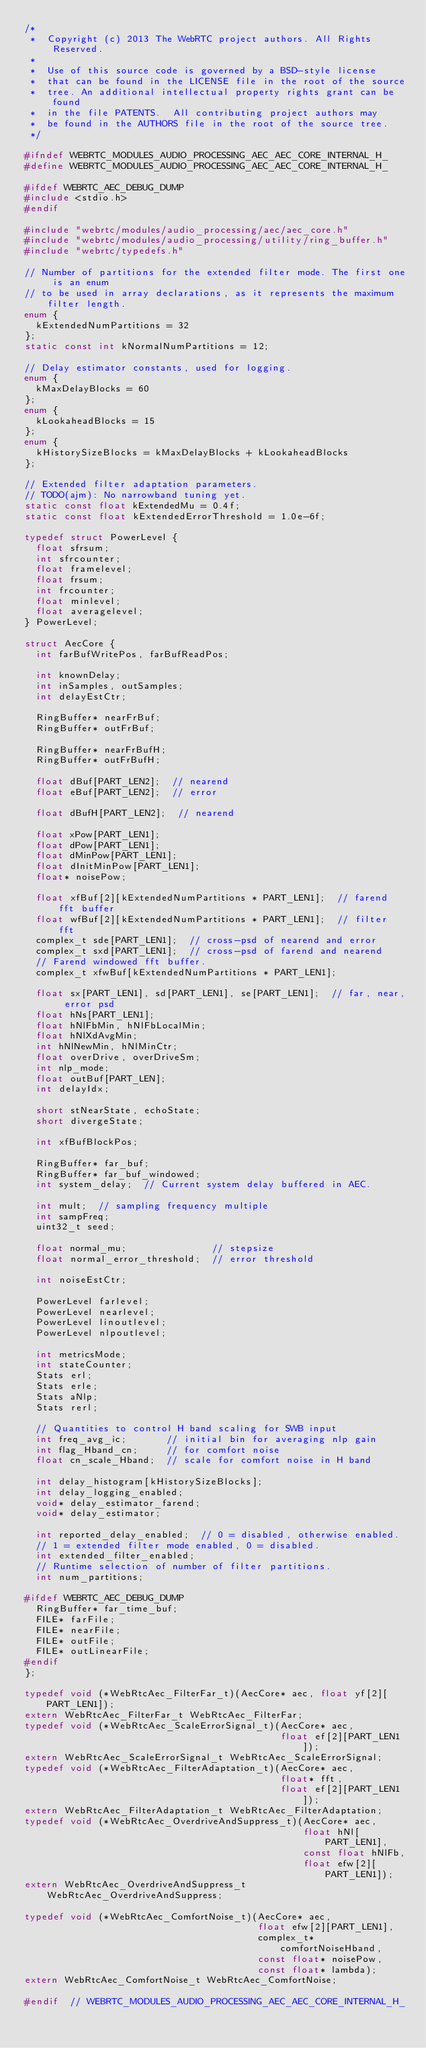<code> <loc_0><loc_0><loc_500><loc_500><_C_>/*
 *  Copyright (c) 2013 The WebRTC project authors. All Rights Reserved.
 *
 *  Use of this source code is governed by a BSD-style license
 *  that can be found in the LICENSE file in the root of the source
 *  tree. An additional intellectual property rights grant can be found
 *  in the file PATENTS.  All contributing project authors may
 *  be found in the AUTHORS file in the root of the source tree.
 */

#ifndef WEBRTC_MODULES_AUDIO_PROCESSING_AEC_AEC_CORE_INTERNAL_H_
#define WEBRTC_MODULES_AUDIO_PROCESSING_AEC_AEC_CORE_INTERNAL_H_

#ifdef WEBRTC_AEC_DEBUG_DUMP
#include <stdio.h>
#endif

#include "webrtc/modules/audio_processing/aec/aec_core.h"
#include "webrtc/modules/audio_processing/utility/ring_buffer.h"
#include "webrtc/typedefs.h"

// Number of partitions for the extended filter mode. The first one is an enum
// to be used in array declarations, as it represents the maximum filter length.
enum {
  kExtendedNumPartitions = 32
};
static const int kNormalNumPartitions = 12;

// Delay estimator constants, used for logging.
enum {
  kMaxDelayBlocks = 60
};
enum {
  kLookaheadBlocks = 15
};
enum {
  kHistorySizeBlocks = kMaxDelayBlocks + kLookaheadBlocks
};

// Extended filter adaptation parameters.
// TODO(ajm): No narrowband tuning yet.
static const float kExtendedMu = 0.4f;
static const float kExtendedErrorThreshold = 1.0e-6f;

typedef struct PowerLevel {
  float sfrsum;
  int sfrcounter;
  float framelevel;
  float frsum;
  int frcounter;
  float minlevel;
  float averagelevel;
} PowerLevel;

struct AecCore {
  int farBufWritePos, farBufReadPos;

  int knownDelay;
  int inSamples, outSamples;
  int delayEstCtr;

  RingBuffer* nearFrBuf;
  RingBuffer* outFrBuf;

  RingBuffer* nearFrBufH;
  RingBuffer* outFrBufH;

  float dBuf[PART_LEN2];  // nearend
  float eBuf[PART_LEN2];  // error

  float dBufH[PART_LEN2];  // nearend

  float xPow[PART_LEN1];
  float dPow[PART_LEN1];
  float dMinPow[PART_LEN1];
  float dInitMinPow[PART_LEN1];
  float* noisePow;

  float xfBuf[2][kExtendedNumPartitions * PART_LEN1];  // farend fft buffer
  float wfBuf[2][kExtendedNumPartitions * PART_LEN1];  // filter fft
  complex_t sde[PART_LEN1];  // cross-psd of nearend and error
  complex_t sxd[PART_LEN1];  // cross-psd of farend and nearend
  // Farend windowed fft buffer.
  complex_t xfwBuf[kExtendedNumPartitions * PART_LEN1];

  float sx[PART_LEN1], sd[PART_LEN1], se[PART_LEN1];  // far, near, error psd
  float hNs[PART_LEN1];
  float hNlFbMin, hNlFbLocalMin;
  float hNlXdAvgMin;
  int hNlNewMin, hNlMinCtr;
  float overDrive, overDriveSm;
  int nlp_mode;
  float outBuf[PART_LEN];
  int delayIdx;

  short stNearState, echoState;
  short divergeState;

  int xfBufBlockPos;

  RingBuffer* far_buf;
  RingBuffer* far_buf_windowed;
  int system_delay;  // Current system delay buffered in AEC.

  int mult;  // sampling frequency multiple
  int sampFreq;
  uint32_t seed;

  float normal_mu;               // stepsize
  float normal_error_threshold;  // error threshold

  int noiseEstCtr;

  PowerLevel farlevel;
  PowerLevel nearlevel;
  PowerLevel linoutlevel;
  PowerLevel nlpoutlevel;

  int metricsMode;
  int stateCounter;
  Stats erl;
  Stats erle;
  Stats aNlp;
  Stats rerl;

  // Quantities to control H band scaling for SWB input
  int freq_avg_ic;       // initial bin for averaging nlp gain
  int flag_Hband_cn;     // for comfort noise
  float cn_scale_Hband;  // scale for comfort noise in H band

  int delay_histogram[kHistorySizeBlocks];
  int delay_logging_enabled;
  void* delay_estimator_farend;
  void* delay_estimator;

  int reported_delay_enabled;  // 0 = disabled, otherwise enabled.
  // 1 = extended filter mode enabled, 0 = disabled.
  int extended_filter_enabled;
  // Runtime selection of number of filter partitions.
  int num_partitions;

#ifdef WEBRTC_AEC_DEBUG_DUMP
  RingBuffer* far_time_buf;
  FILE* farFile;
  FILE* nearFile;
  FILE* outFile;
  FILE* outLinearFile;
#endif
};

typedef void (*WebRtcAec_FilterFar_t)(AecCore* aec, float yf[2][PART_LEN1]);
extern WebRtcAec_FilterFar_t WebRtcAec_FilterFar;
typedef void (*WebRtcAec_ScaleErrorSignal_t)(AecCore* aec,
                                             float ef[2][PART_LEN1]);
extern WebRtcAec_ScaleErrorSignal_t WebRtcAec_ScaleErrorSignal;
typedef void (*WebRtcAec_FilterAdaptation_t)(AecCore* aec,
                                             float* fft,
                                             float ef[2][PART_LEN1]);
extern WebRtcAec_FilterAdaptation_t WebRtcAec_FilterAdaptation;
typedef void (*WebRtcAec_OverdriveAndSuppress_t)(AecCore* aec,
                                                 float hNl[PART_LEN1],
                                                 const float hNlFb,
                                                 float efw[2][PART_LEN1]);
extern WebRtcAec_OverdriveAndSuppress_t WebRtcAec_OverdriveAndSuppress;

typedef void (*WebRtcAec_ComfortNoise_t)(AecCore* aec,
                                         float efw[2][PART_LEN1],
                                         complex_t* comfortNoiseHband,
                                         const float* noisePow,
                                         const float* lambda);
extern WebRtcAec_ComfortNoise_t WebRtcAec_ComfortNoise;

#endif  // WEBRTC_MODULES_AUDIO_PROCESSING_AEC_AEC_CORE_INTERNAL_H_
</code> 